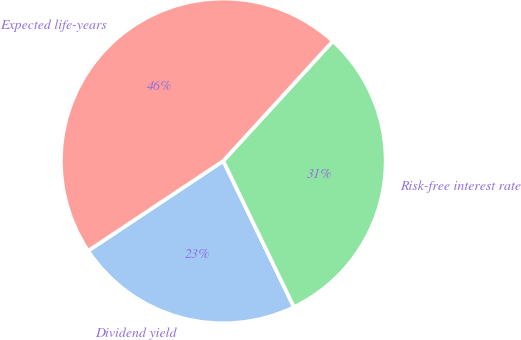<chart> <loc_0><loc_0><loc_500><loc_500><pie_chart><fcel>Dividend yield<fcel>Risk-free interest rate<fcel>Expected life-years<nl><fcel>22.83%<fcel>31.04%<fcel>46.13%<nl></chart> 